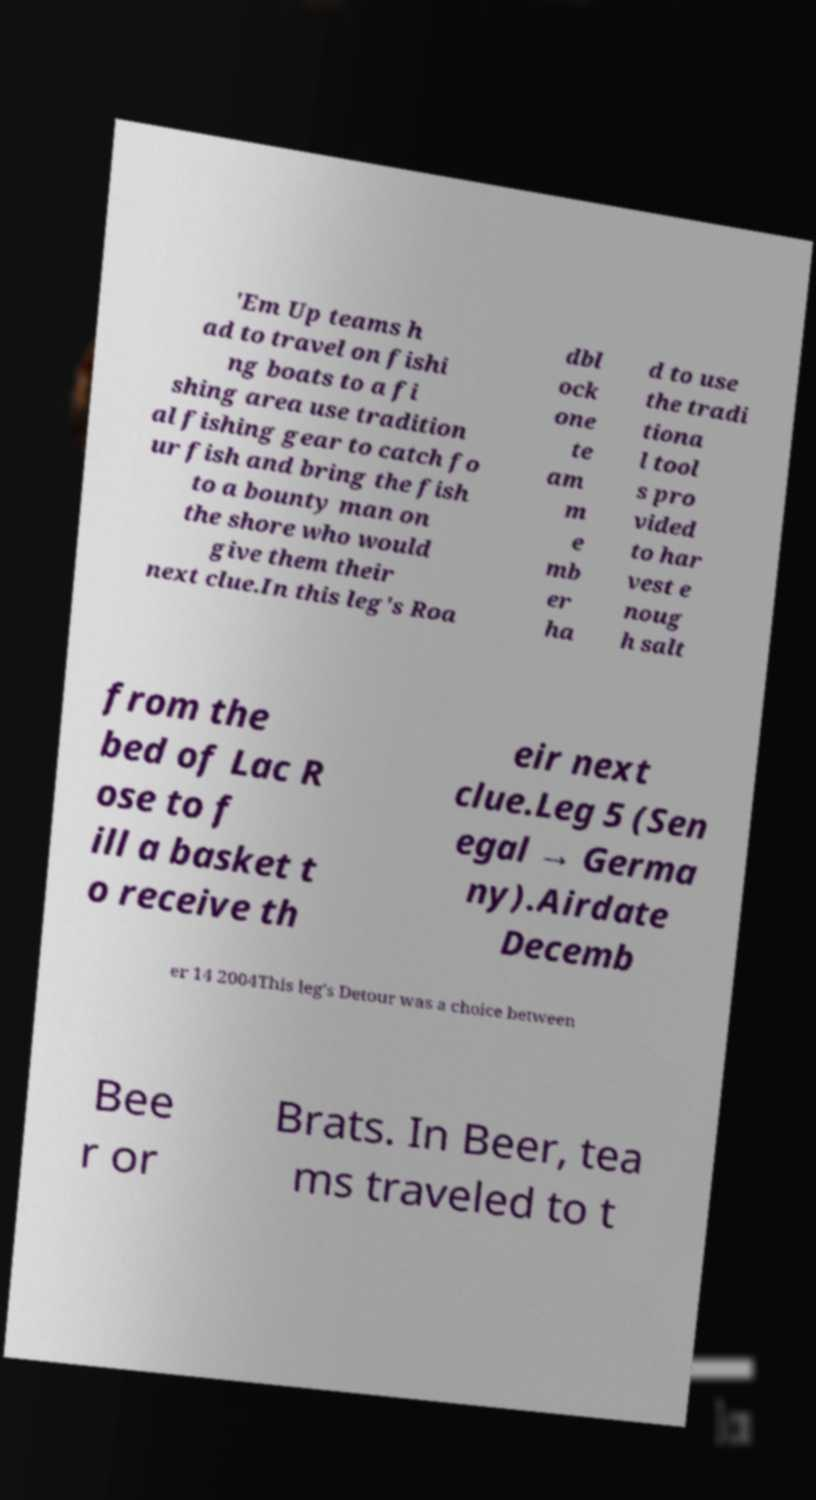Can you read and provide the text displayed in the image?This photo seems to have some interesting text. Can you extract and type it out for me? 'Em Up teams h ad to travel on fishi ng boats to a fi shing area use tradition al fishing gear to catch fo ur fish and bring the fish to a bounty man on the shore who would give them their next clue.In this leg's Roa dbl ock one te am m e mb er ha d to use the tradi tiona l tool s pro vided to har vest e noug h salt from the bed of Lac R ose to f ill a basket t o receive th eir next clue.Leg 5 (Sen egal → Germa ny).Airdate Decemb er 14 2004This leg's Detour was a choice between Bee r or Brats. In Beer, tea ms traveled to t 